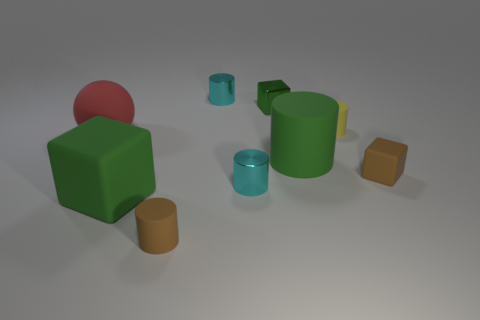Subtract all red cylinders. Subtract all cyan spheres. How many cylinders are left? 5 Subtract all spheres. How many objects are left? 8 Add 4 large red objects. How many large red objects are left? 5 Add 7 tiny green matte balls. How many tiny green matte balls exist? 7 Subtract 2 cyan cylinders. How many objects are left? 7 Subtract all small green things. Subtract all yellow matte cylinders. How many objects are left? 7 